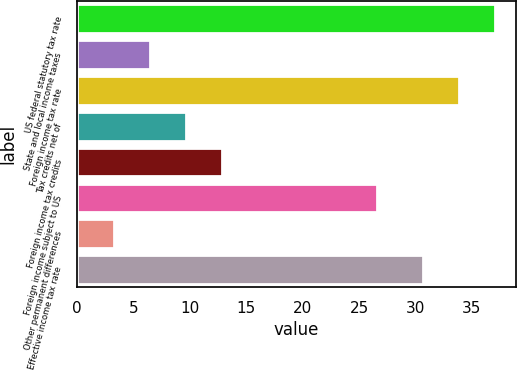<chart> <loc_0><loc_0><loc_500><loc_500><bar_chart><fcel>US federal statutory tax rate<fcel>State and local income taxes<fcel>Foreign income tax rate<fcel>Tax credits net of<fcel>Foreign income tax credits<fcel>Foreign income subject to US<fcel>Other permanent differences<fcel>Effective income tax rate<nl><fcel>37.04<fcel>6.47<fcel>33.87<fcel>9.64<fcel>12.81<fcel>26.6<fcel>3.3<fcel>30.7<nl></chart> 